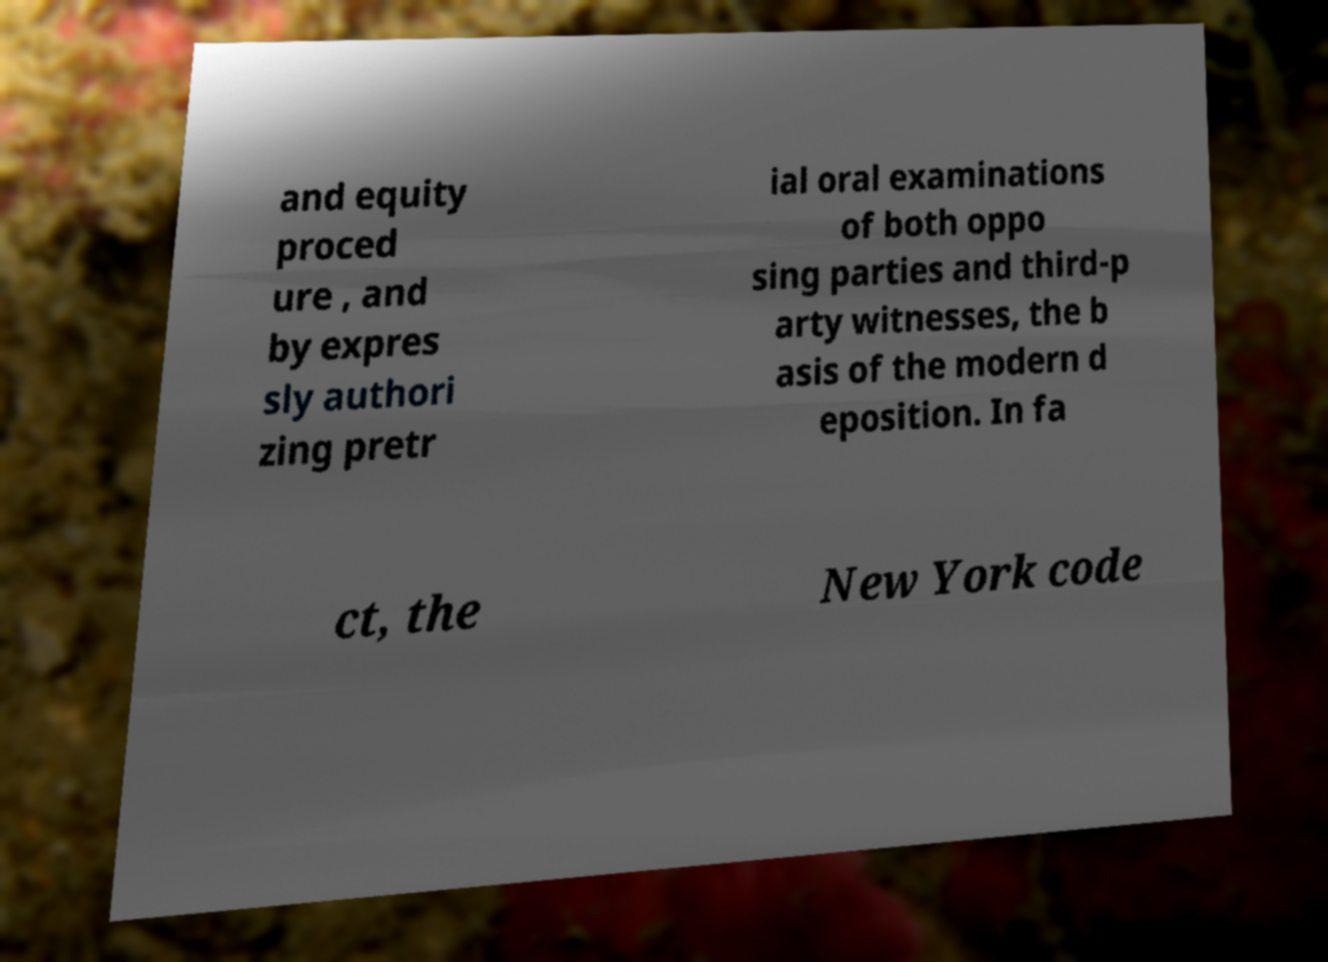Can you read and provide the text displayed in the image?This photo seems to have some interesting text. Can you extract and type it out for me? and equity proced ure , and by expres sly authori zing pretr ial oral examinations of both oppo sing parties and third-p arty witnesses, the b asis of the modern d eposition. In fa ct, the New York code 